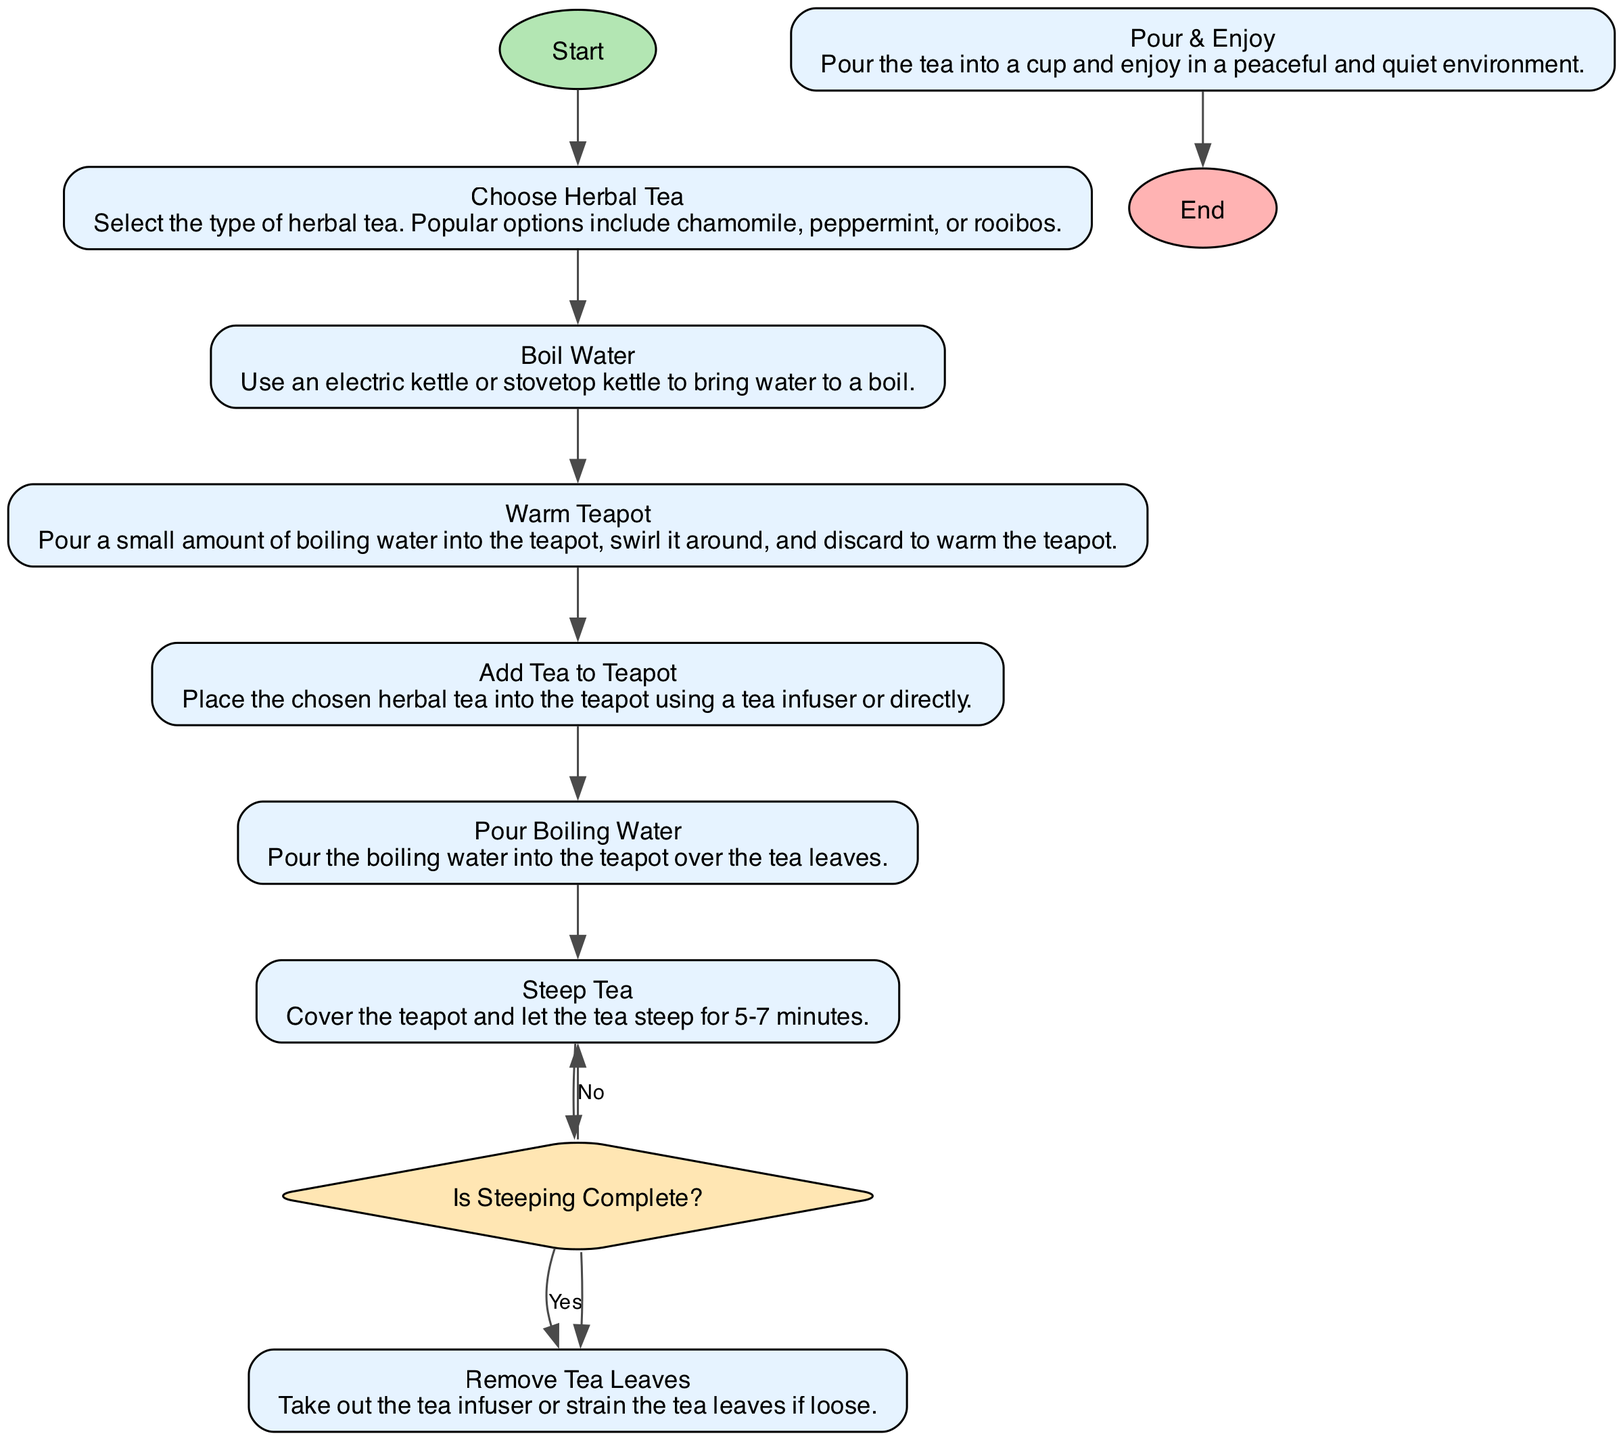What is the first step in preparing herbal tea? The first step in the flowchart is "Choose Herbal Tea," as indicated by the first node after the "Start" node.
Answer: Choose Herbal Tea How many steps are there in total, including decisions? Counting all the steps, including the decision point, there are 9 steps from starting to pouring and enjoying the tea.
Answer: 9 What is the decision point in the diagram? The decision point in the flowchart is labeled "Is Steeping Complete?" and is represented as a diamond shape, indicating a choice is required.
Answer: Is Steeping Complete? What action follows boiling water? Following "Boil Water," the next action is "Warm Teapot," which is directly connected by an edge in the flowchart.
Answer: Warm Teapot What should you do if the tea is not steeped? If the tea is not steeped, you should repeat the action of "Steep Tea," as indicated by the "No" branch of the decision node.
Answer: Steep Tea How long should the tea steep? The flowchart specifies that the tea should steep for 5-7 minutes as part of the "Steep Tea" action description.
Answer: 5-7 minutes What is the final action taken before the end of the process? The final action before ending the process is "Pour & Enjoy," as it is the last action explicitly listed before reaching the "End" node.
Answer: Pour & Enjoy If the answer to the decision is "Yes," which action follows? If the answer to "Is Steeping Complete?" is "Yes," the action that follows is "Remove Tea Leaves," as indicated by the "Yes" edge leading to that node.
Answer: Remove Tea Leaves 